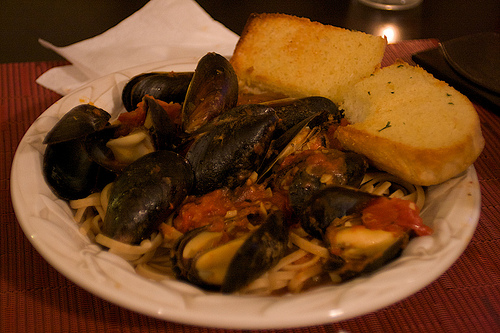<image>
Can you confirm if the mussels is under the pasta? No. The mussels is not positioned under the pasta. The vertical relationship between these objects is different. 